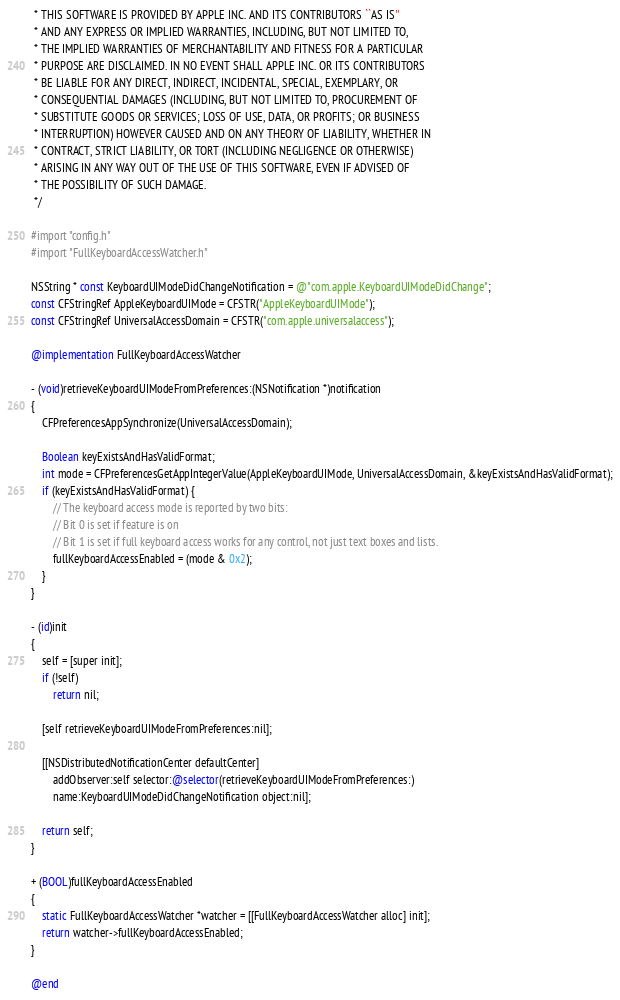Convert code to text. <code><loc_0><loc_0><loc_500><loc_500><_ObjectiveC_> * THIS SOFTWARE IS PROVIDED BY APPLE INC. AND ITS CONTRIBUTORS ``AS IS''
 * AND ANY EXPRESS OR IMPLIED WARRANTIES, INCLUDING, BUT NOT LIMITED TO,
 * THE IMPLIED WARRANTIES OF MERCHANTABILITY AND FITNESS FOR A PARTICULAR
 * PURPOSE ARE DISCLAIMED. IN NO EVENT SHALL APPLE INC. OR ITS CONTRIBUTORS
 * BE LIABLE FOR ANY DIRECT, INDIRECT, INCIDENTAL, SPECIAL, EXEMPLARY, OR
 * CONSEQUENTIAL DAMAGES (INCLUDING, BUT NOT LIMITED TO, PROCUREMENT OF
 * SUBSTITUTE GOODS OR SERVICES; LOSS OF USE, DATA, OR PROFITS; OR BUSINESS
 * INTERRUPTION) HOWEVER CAUSED AND ON ANY THEORY OF LIABILITY, WHETHER IN
 * CONTRACT, STRICT LIABILITY, OR TORT (INCLUDING NEGLIGENCE OR OTHERWISE)
 * ARISING IN ANY WAY OUT OF THE USE OF THIS SOFTWARE, EVEN IF ADVISED OF
 * THE POSSIBILITY OF SUCH DAMAGE.
 */

#import "config.h"
#import "FullKeyboardAccessWatcher.h"

NSString * const KeyboardUIModeDidChangeNotification = @"com.apple.KeyboardUIModeDidChange";
const CFStringRef AppleKeyboardUIMode = CFSTR("AppleKeyboardUIMode");
const CFStringRef UniversalAccessDomain = CFSTR("com.apple.universalaccess");

@implementation FullKeyboardAccessWatcher

- (void)retrieveKeyboardUIModeFromPreferences:(NSNotification *)notification
{
    CFPreferencesAppSynchronize(UniversalAccessDomain);

    Boolean keyExistsAndHasValidFormat;
    int mode = CFPreferencesGetAppIntegerValue(AppleKeyboardUIMode, UniversalAccessDomain, &keyExistsAndHasValidFormat);
    if (keyExistsAndHasValidFormat) {
        // The keyboard access mode is reported by two bits:
        // Bit 0 is set if feature is on
        // Bit 1 is set if full keyboard access works for any control, not just text boxes and lists.
        fullKeyboardAccessEnabled = (mode & 0x2);
    }
}

- (id)init
{
    self = [super init];
    if (!self)
        return nil;

    [self retrieveKeyboardUIModeFromPreferences:nil];

    [[NSDistributedNotificationCenter defaultCenter] 
        addObserver:self selector:@selector(retrieveKeyboardUIModeFromPreferences:) 
        name:KeyboardUIModeDidChangeNotification object:nil];

    return self;
}

+ (BOOL)fullKeyboardAccessEnabled
{
    static FullKeyboardAccessWatcher *watcher = [[FullKeyboardAccessWatcher alloc] init];
    return watcher->fullKeyboardAccessEnabled;
}

@end
</code> 